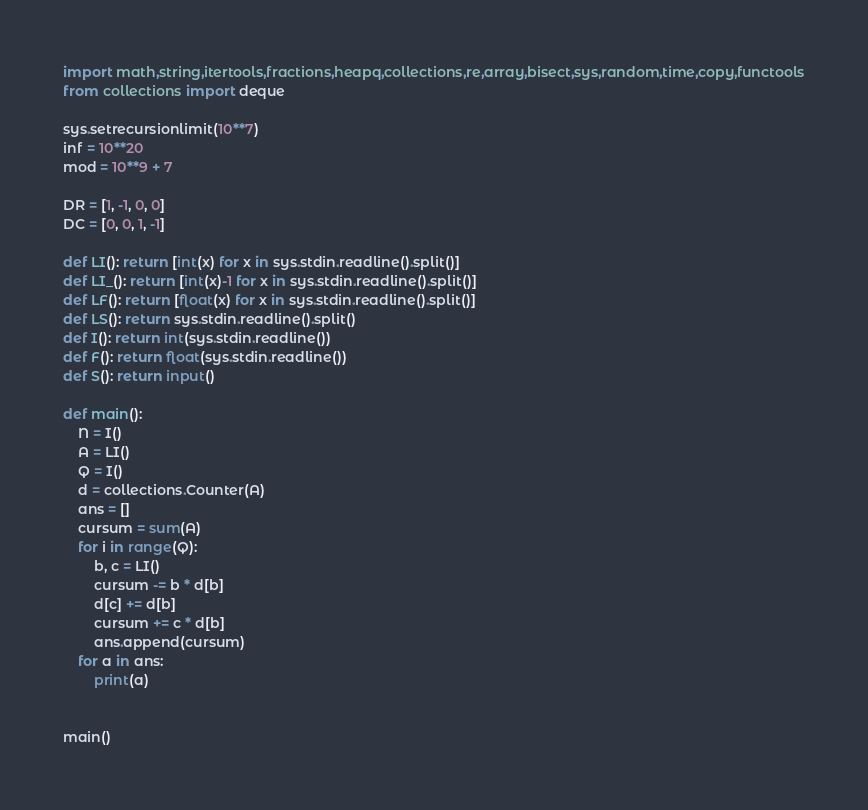<code> <loc_0><loc_0><loc_500><loc_500><_Python_>import math,string,itertools,fractions,heapq,collections,re,array,bisect,sys,random,time,copy,functools
from collections import deque

sys.setrecursionlimit(10**7)
inf = 10**20
mod = 10**9 + 7

DR = [1, -1, 0, 0]
DC = [0, 0, 1, -1]

def LI(): return [int(x) for x in sys.stdin.readline().split()]
def LI_(): return [int(x)-1 for x in sys.stdin.readline().split()]
def LF(): return [float(x) for x in sys.stdin.readline().split()]
def LS(): return sys.stdin.readline().split()
def I(): return int(sys.stdin.readline())
def F(): return float(sys.stdin.readline())
def S(): return input()
     
def main():
    N = I()
    A = LI()
    Q = I()
    d = collections.Counter(A)
    ans = []
    cursum = sum(A)
    for i in range(Q):
        b, c = LI()
        cursum -= b * d[b]
        d[c] += d[b]
        cursum += c * d[b]
        ans.append(cursum)
    for a in ans:
        print(a)


main()

</code> 